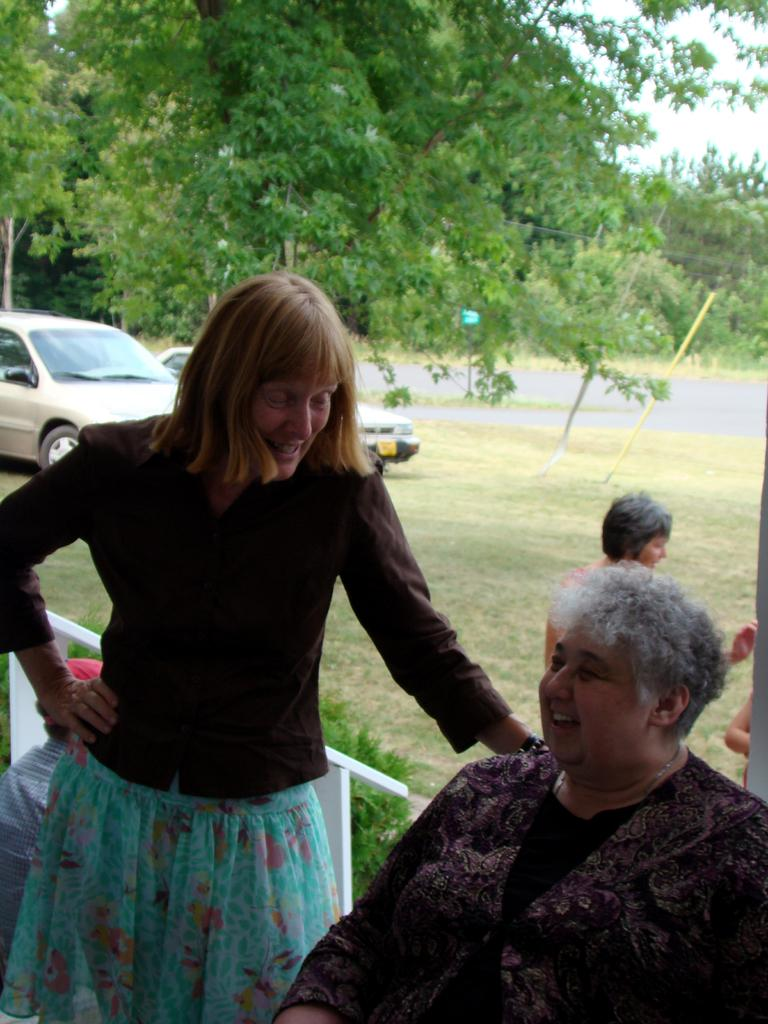How many people are in the image? There are people in the image, but the exact number is not specified. What type of vegetation is present in the image? There are plants, grass, and trees in the image. What type of transportation is visible in the image? There are vehicles in the image. What part of the natural environment is visible in the image? The sky is visible in the image. What type of pathway is present in the image? There is a road in the image. What direction are the people in the image helping the plants to measure? There is no indication in the image that the people are helping the plants to measure anything, nor is there any reference to a specific direction. 